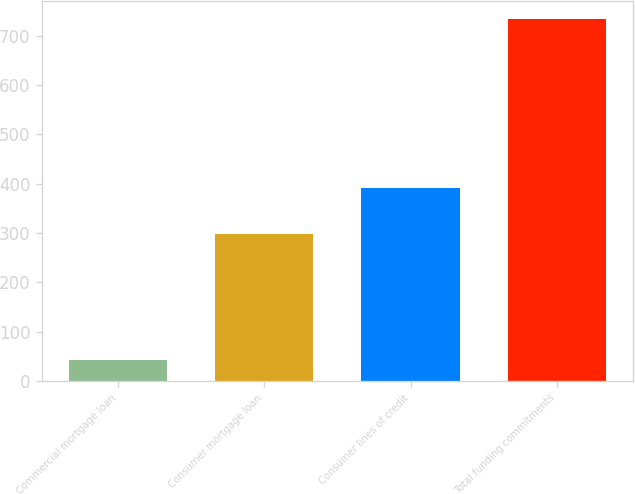Convert chart to OTSL. <chart><loc_0><loc_0><loc_500><loc_500><bar_chart><fcel>Commercial mortgage loan<fcel>Consumer mortgage loan<fcel>Consumer lines of credit<fcel>Total funding commitments<nl><fcel>44<fcel>298<fcel>392<fcel>734<nl></chart> 